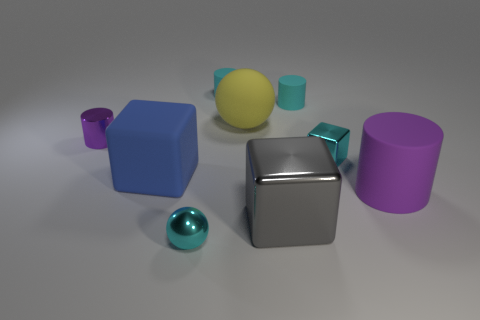What number of other large balls have the same material as the big ball?
Your answer should be compact. 0. There is a object that is the same color as the tiny metallic cylinder; what is its shape?
Keep it short and to the point. Cylinder. There is a metallic cube behind the big object left of the cyan sphere; what size is it?
Make the answer very short. Small. Is the shape of the cyan shiny object that is to the left of the yellow sphere the same as the shiny thing to the left of the tiny cyan metallic sphere?
Your answer should be very brief. No. Are there an equal number of cyan balls on the left side of the large purple rubber object and cubes?
Provide a short and direct response. No. The tiny object that is the same shape as the large yellow rubber object is what color?
Your response must be concise. Cyan. Do the purple cylinder in front of the blue thing and the small purple thing have the same material?
Provide a short and direct response. No. How many large things are either blue blocks or red matte blocks?
Your answer should be very brief. 1. What size is the yellow thing?
Ensure brevity in your answer.  Large. Is the size of the gray object the same as the cyan rubber cylinder to the right of the gray shiny block?
Offer a terse response. No. 